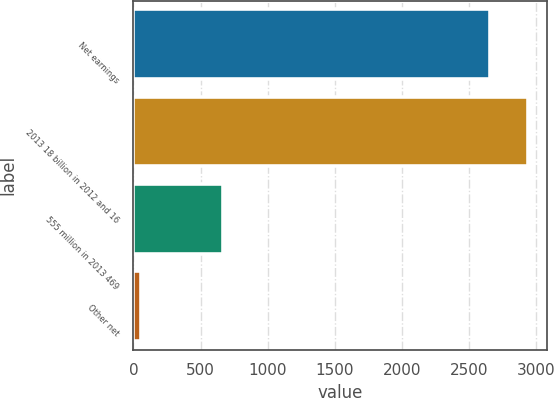Convert chart to OTSL. <chart><loc_0><loc_0><loc_500><loc_500><bar_chart><fcel>Net earnings<fcel>2013 18 billion in 2012 and 16<fcel>555 million in 2013 469<fcel>Other net<nl><fcel>2655<fcel>2935.3<fcel>666<fcel>55<nl></chart> 